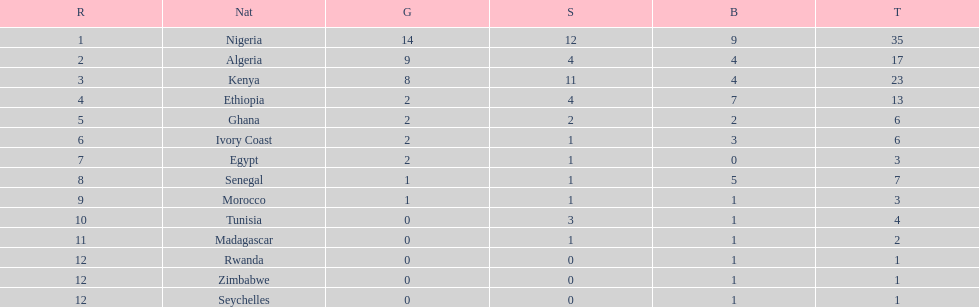What is the name of the first nation on this chart? Nigeria. 